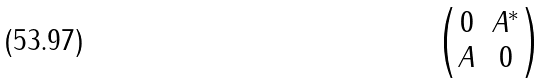<formula> <loc_0><loc_0><loc_500><loc_500>\begin{pmatrix} 0 & A ^ { * } \\ A & 0 \end{pmatrix}</formula> 